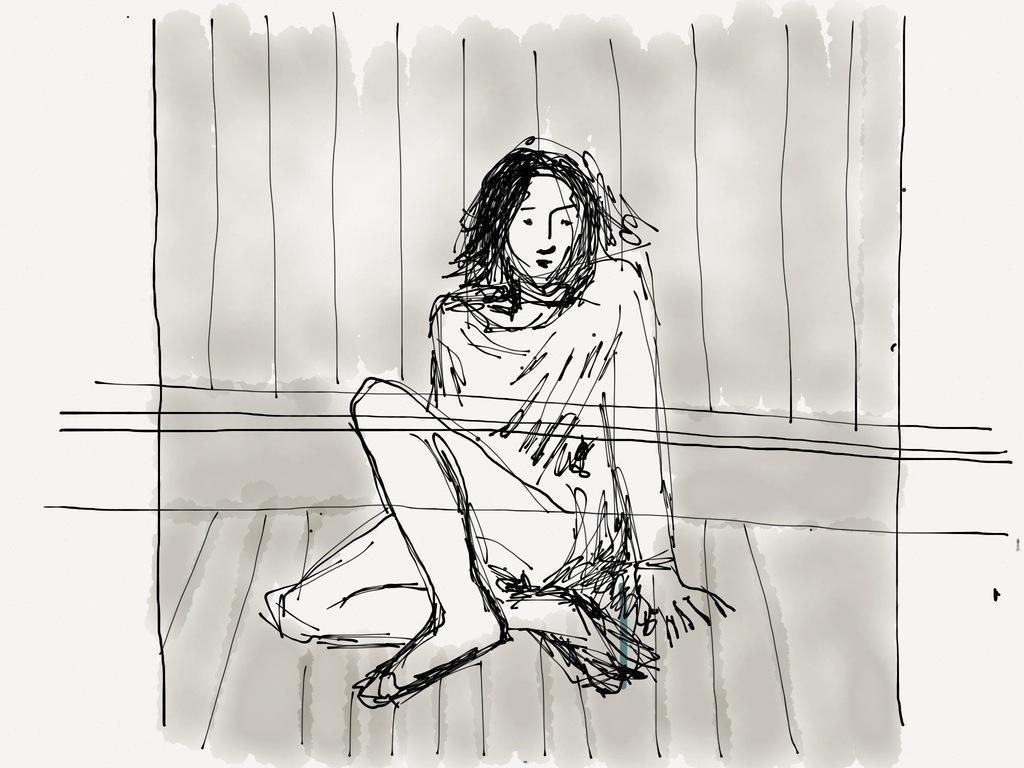Please provide a concise description of this image. In this picture we can see a sketch of a woman sitting on a surface. 